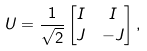<formula> <loc_0><loc_0><loc_500><loc_500>U & = \frac { 1 } { \sqrt { 2 } } \begin{bmatrix} I & I \\ J & - J \end{bmatrix} ,</formula> 